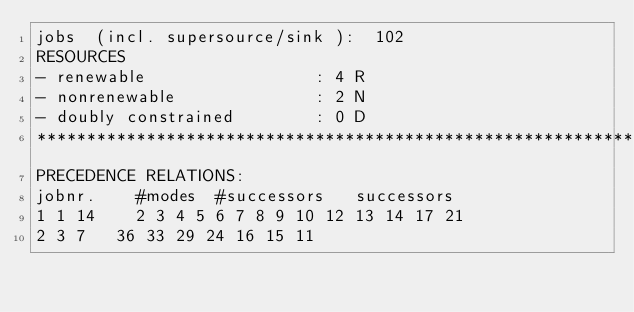Convert code to text. <code><loc_0><loc_0><loc_500><loc_500><_ObjectiveC_>jobs  (incl. supersource/sink ):	102
RESOURCES
- renewable                 : 4 R
- nonrenewable              : 2 N
- doubly constrained        : 0 D
************************************************************************
PRECEDENCE RELATIONS:
jobnr.    #modes  #successors   successors
1	1	14		2 3 4 5 6 7 8 9 10 12 13 14 17 21 
2	3	7		36 33 29 24 16 15 11 </code> 